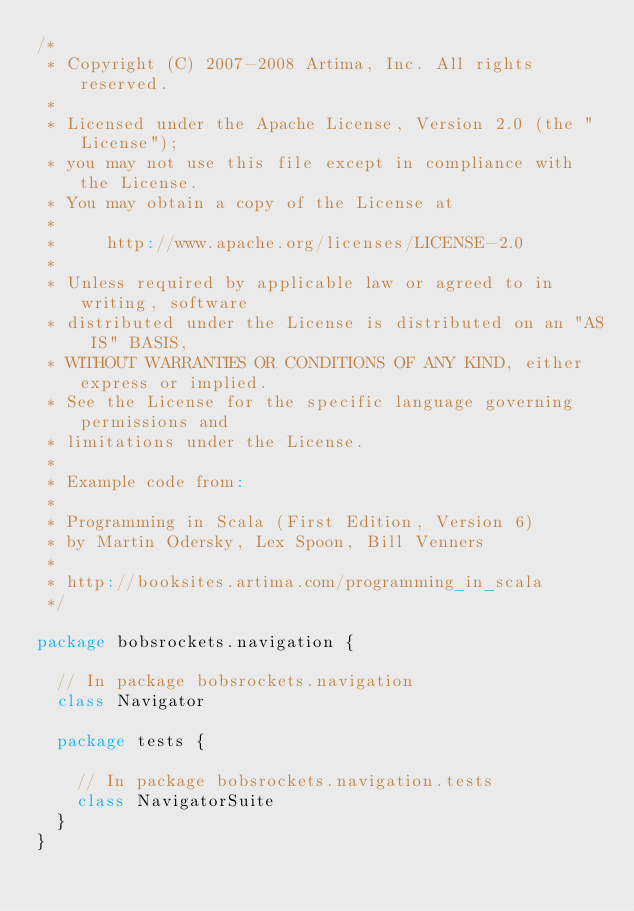<code> <loc_0><loc_0><loc_500><loc_500><_Scala_>/*
 * Copyright (C) 2007-2008 Artima, Inc. All rights reserved.
 * 
 * Licensed under the Apache License, Version 2.0 (the "License");
 * you may not use this file except in compliance with the License.
 * You may obtain a copy of the License at
 * 
 *     http://www.apache.org/licenses/LICENSE-2.0
 * 
 * Unless required by applicable law or agreed to in writing, software
 * distributed under the License is distributed on an "AS IS" BASIS,
 * WITHOUT WARRANTIES OR CONDITIONS OF ANY KIND, either express or implied.
 * See the License for the specific language governing permissions and
 * limitations under the License.
 *
 * Example code from:
 *
 * Programming in Scala (First Edition, Version 6)
 * by Martin Odersky, Lex Spoon, Bill Venners
 *
 * http://booksites.artima.com/programming_in_scala
 */

package bobsrockets.navigation {

  // In package bobsrockets.navigation
  class Navigator

  package tests {

    // In package bobsrockets.navigation.tests
    class NavigatorSuite
  }
}
</code> 